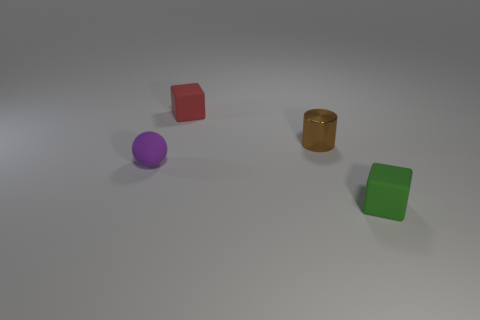There is another tiny thing that is the same shape as the green thing; what is its color?
Your response must be concise. Red. Is there anything else that has the same shape as the tiny red matte object?
Your response must be concise. Yes. There is a block that is to the right of the shiny object; what is its material?
Keep it short and to the point. Rubber. There is another rubber object that is the same shape as the red thing; what size is it?
Offer a terse response. Small. How many tiny green cylinders are made of the same material as the green block?
Offer a terse response. 0. How many tiny rubber spheres are the same color as the small metallic cylinder?
Make the answer very short. 0. How many objects are matte cubes that are behind the green block or objects that are in front of the tiny purple object?
Make the answer very short. 2. Are there fewer tiny purple rubber things in front of the brown thing than small yellow spheres?
Keep it short and to the point. No. Is there a brown metallic cylinder that has the same size as the red cube?
Provide a succinct answer. Yes. What is the color of the small shiny cylinder?
Your answer should be compact. Brown. 